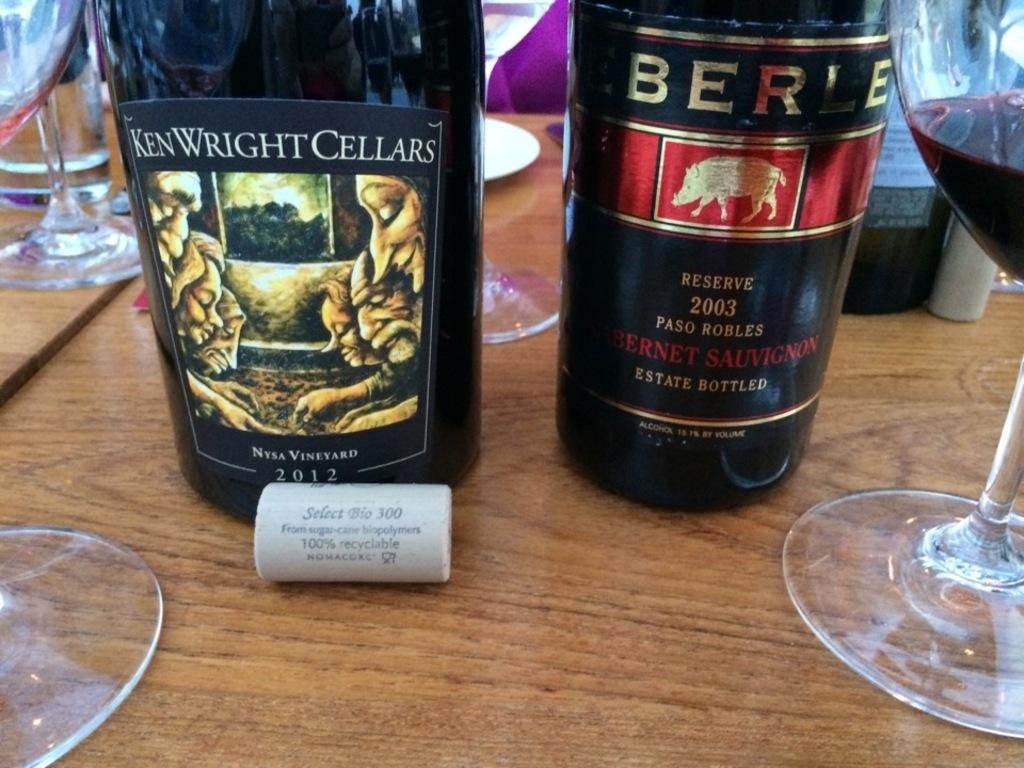What is the color of the table in the image? The table in the image is brown. What type of containers can be seen on the table? There are two glass bottles and a glass containing wine on the table. What other items are on the table? There are glasses, a water glass, a white plate, and a box on the table. How many oranges are on the floor in the image? There are no oranges present in the image, and the floor is not visible in the image. 